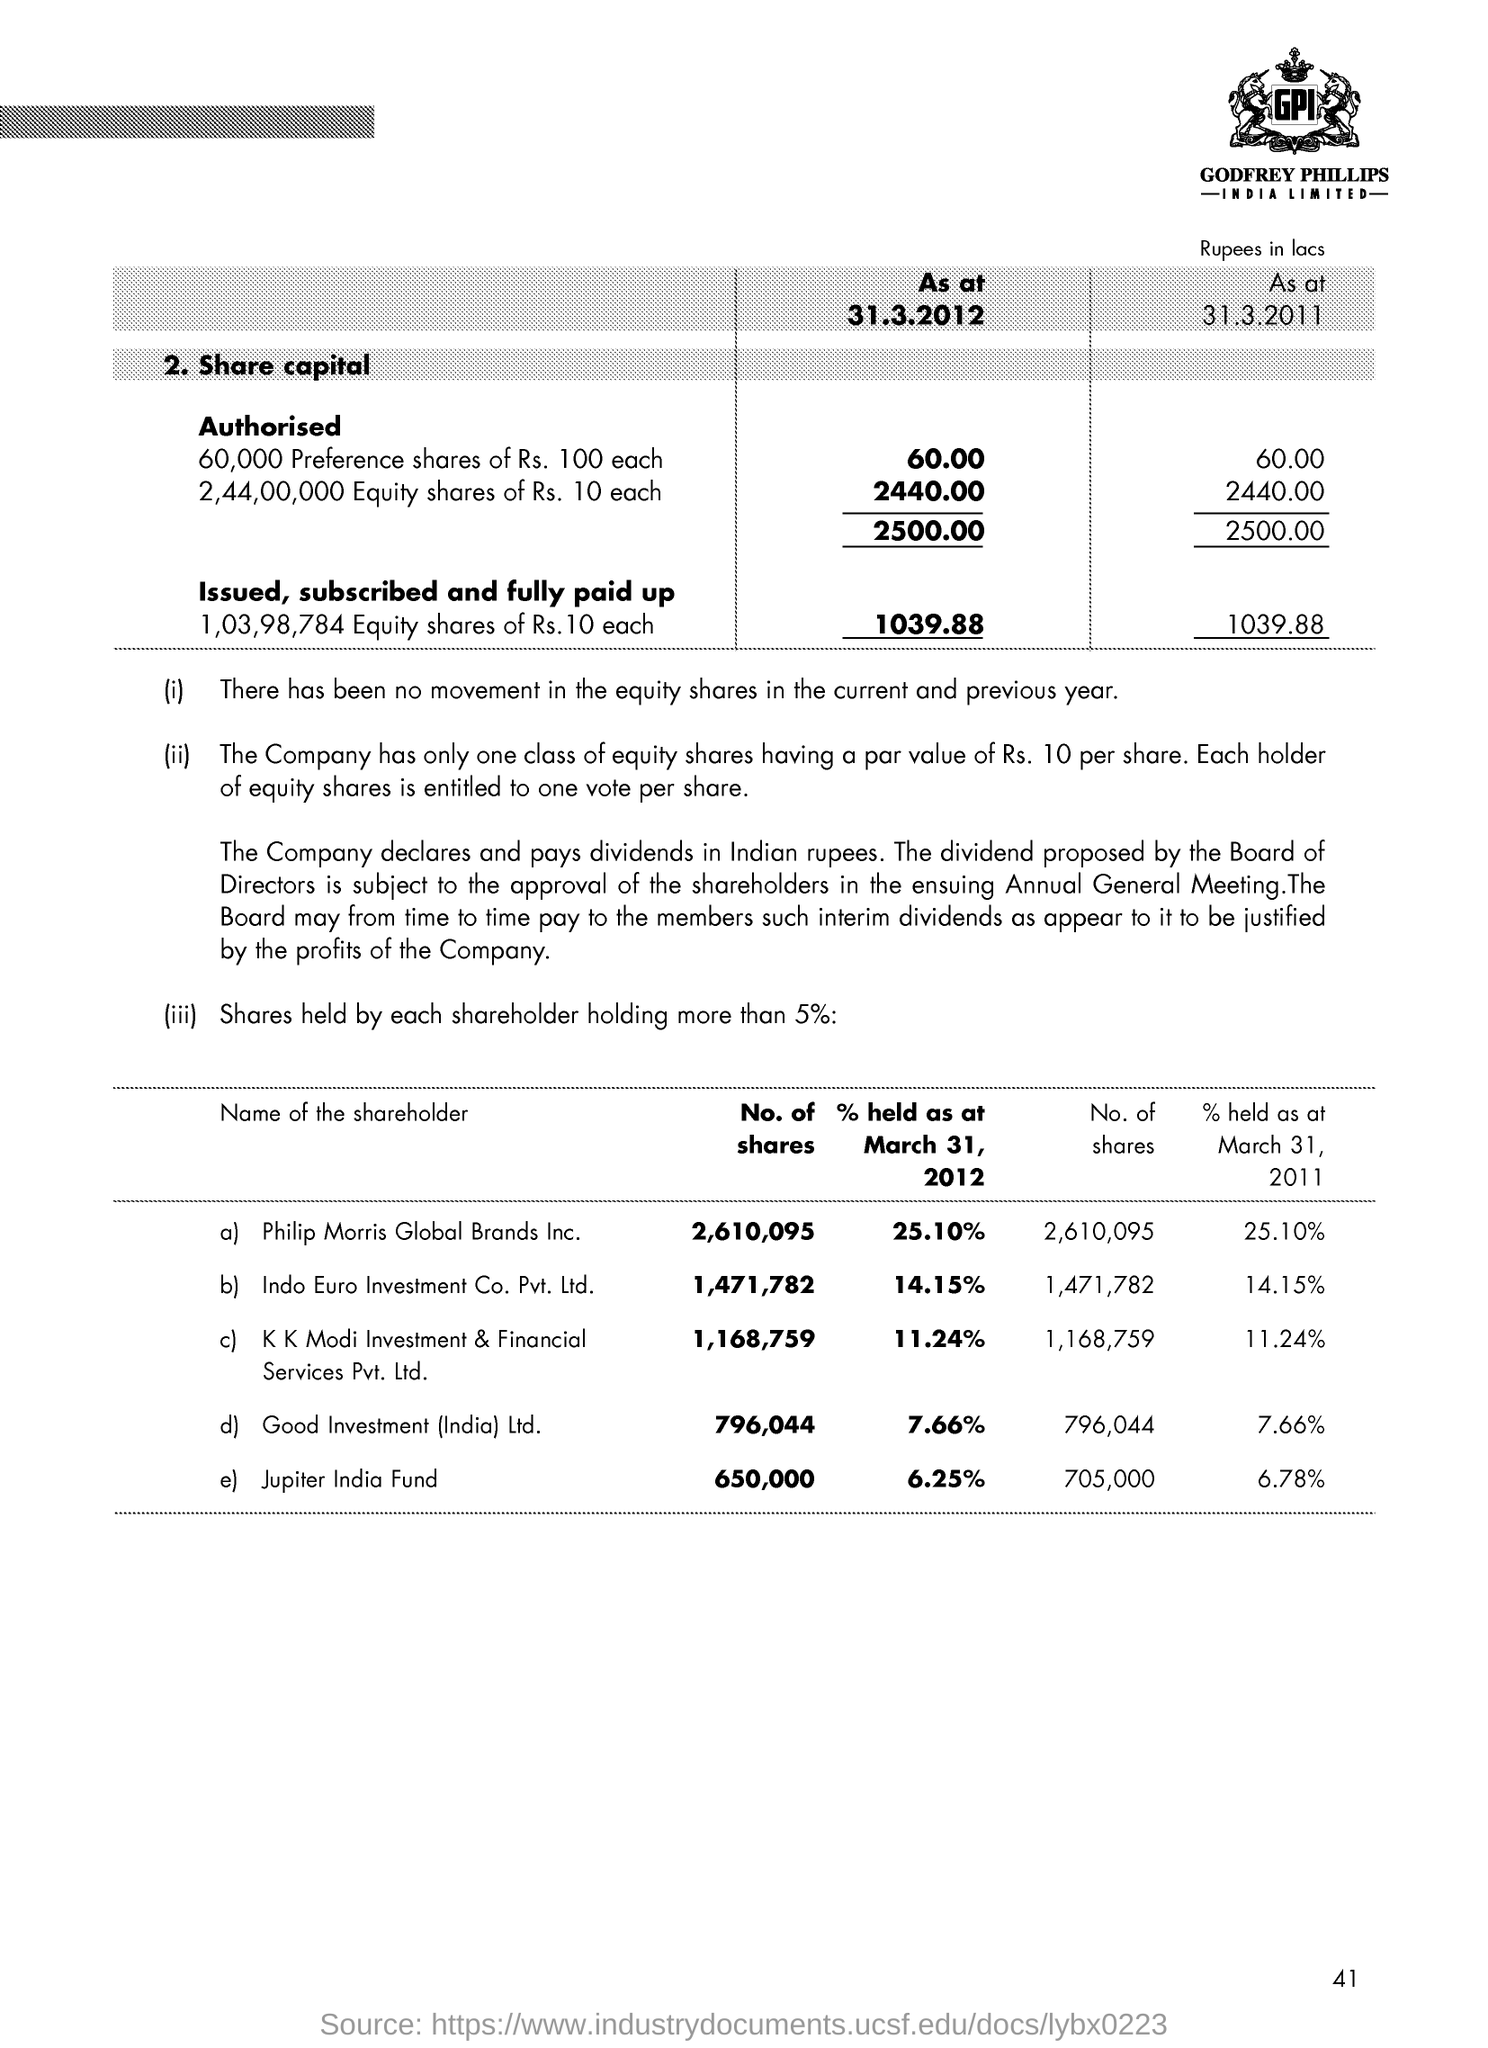What is the Page Number?
Give a very brief answer. 41. What is the number of shares held by Philip Morris Global Brands Inc. as of March 31,2012 ?
Offer a very short reply. 2,610,095. What is the percentage of shares held by Philip Morris Global Brands Inc. as of March 31,2012?
Offer a terse response. 25.10%. Which shareholder held the minimum number of shares as of March 31,2012?
Offer a very short reply. Jupiter India Fund. What is the percentage of shares held by Jupiter India Fund as of March 31,2011?
Your response must be concise. 6.78%. Which shareholder held the maximum number of shares as of March 31,2012?
Offer a very short reply. Philip Morris Global Brands Inc. 